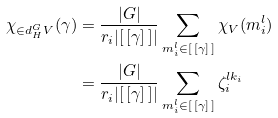<formula> <loc_0><loc_0><loc_500><loc_500>\chi _ { \in d ^ { G } _ { H } V } ( \gamma ) & = \frac { | G | } { r _ { i } | [ \, [ \gamma ] \, ] | } \sum _ { m ^ { l } _ { i } \in [ \, [ \gamma ] \, ] } \chi _ { V } ( m ^ { l } _ { i } ) \\ & = \frac { | G | } { r _ { i } | [ \, [ \gamma ] \, ] | } \sum _ { m ^ { l } _ { i } \in [ \, [ \gamma ] \, ] } \zeta ^ { l k _ { i } } _ { i }</formula> 